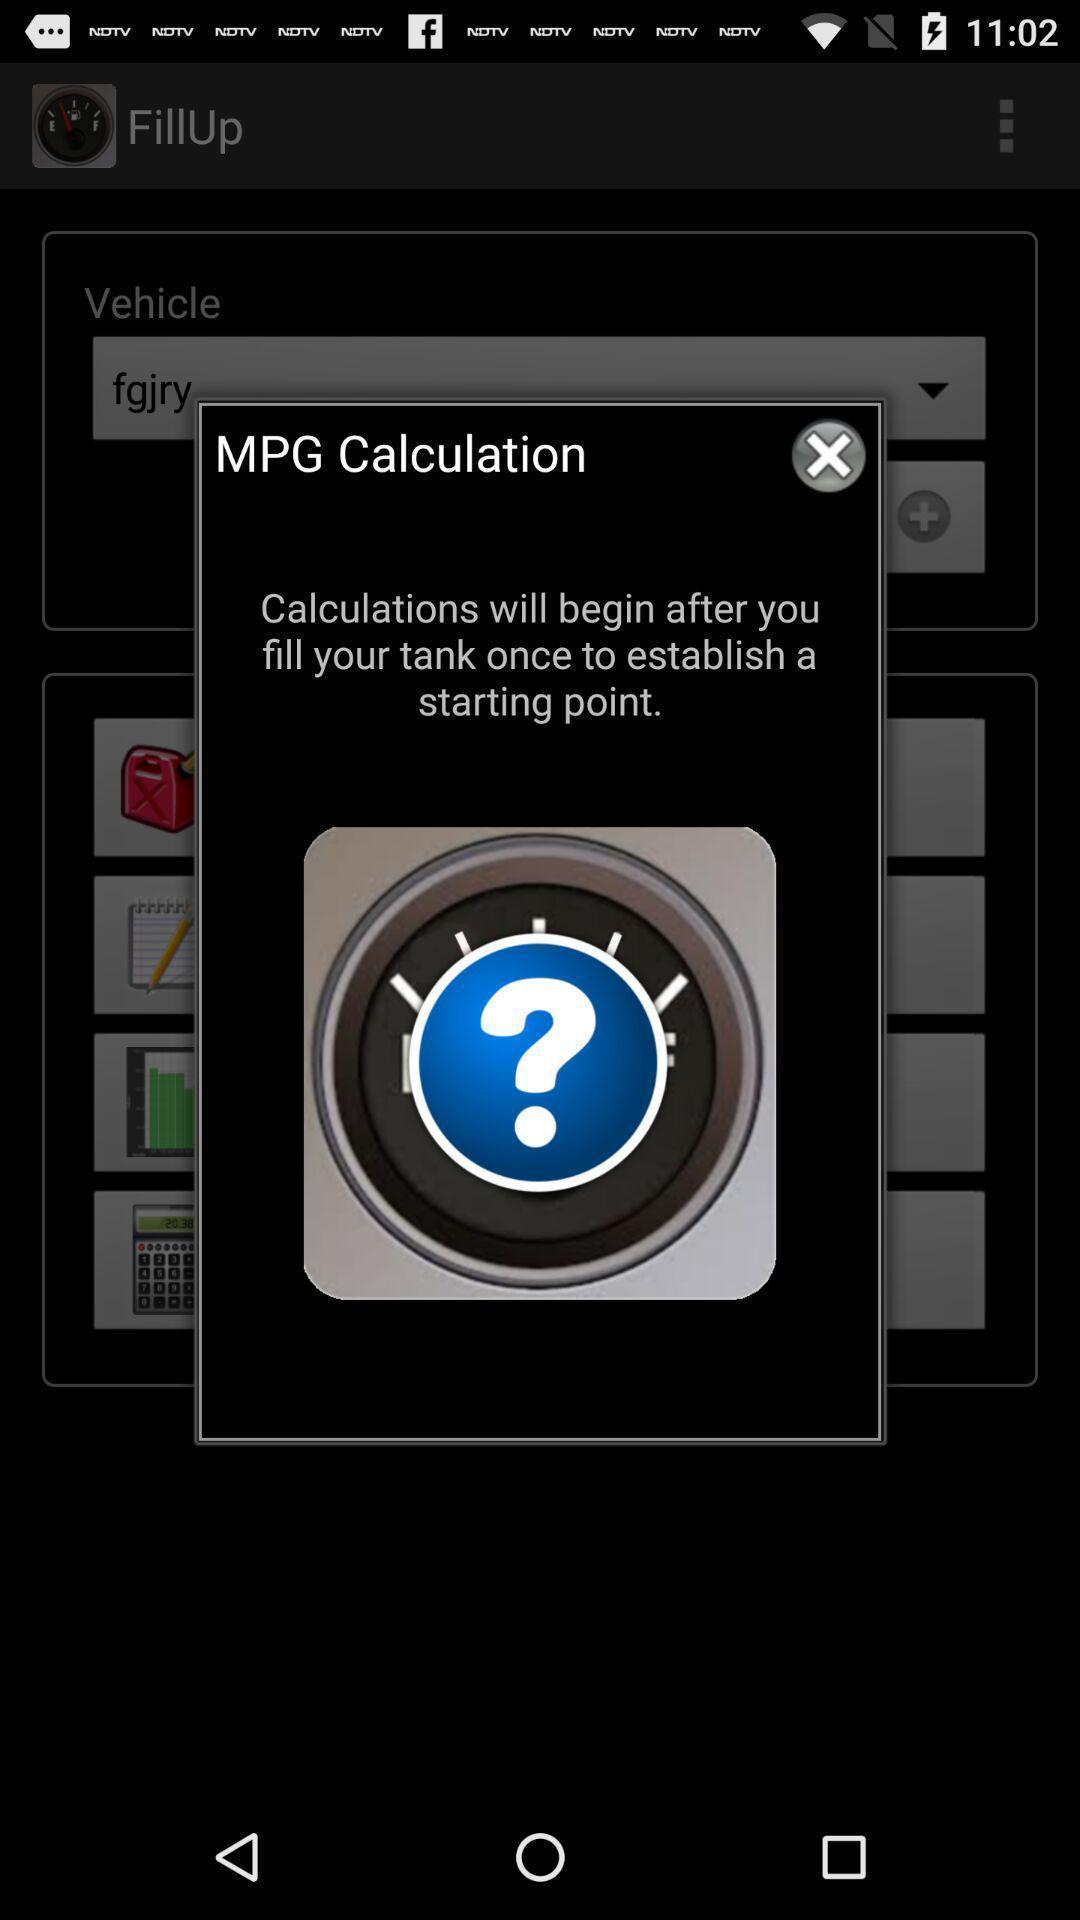Provide a detailed account of this screenshot. Pop-up shows mpg calculation message. 